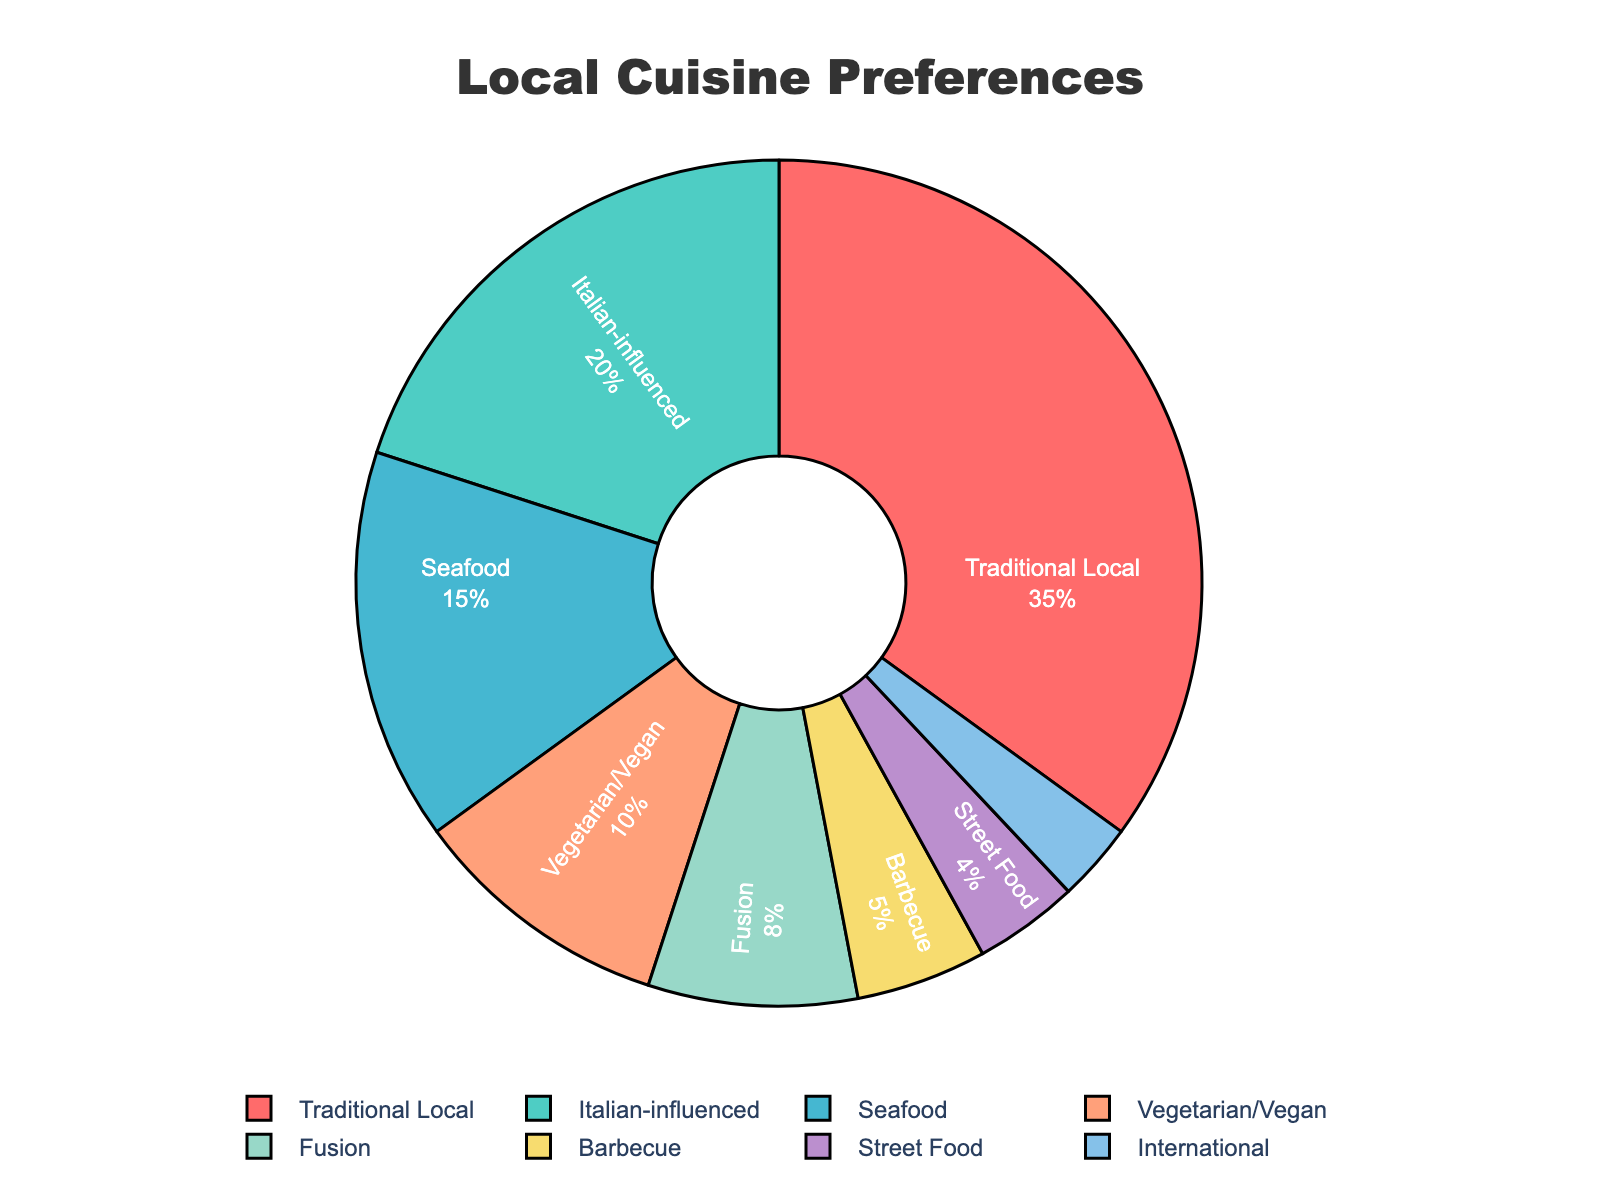Which cuisine has the highest preference among residents? The pie chart shows the percentage distribution of different cuisines. The slice representing "Traditional Local" is the largest, indicating it has the highest preference.
Answer: Traditional Local Which cuisine has the lowest preference among residents? The pie chart shows the percentage distribution of different cuisines. The smallest slice corresponds to "International" cuisine.
Answer: International How much more popular is Traditional Local cuisine compared to Barbecue? The pie chart shows Traditional Local at 35% and Barbecue at 5%. The difference in their popularity is 35% - 5%.
Answer: 30% What is the combined percentage of Seafood and Vegetarian/Vegan preferences? The pie chart shows Seafood at 15% and Vegetarian/Vegan at 10%. So, their combined percentage is 15% + 10%.
Answer: 25% Which is more preferred, Seafood or Italian-influenced cuisine, and by how much? The pie chart shows Seafood at 15% and Italian-influenced at 20%. Italian-influenced cuisine is more preferred by a difference of 20% - 15%.
Answer: Italian-influenced, 5% If you were to combine the categories of Street Food, Barbecue, and International, what would their total percentage be? The pie chart shows Street Food at 4%, Barbecue at 5%, and International at 3%. The combined total is 4% + 5% + 3%.
Answer: 12% What percentage of the preferences is accounted for by cuisines other than Traditional Local, Italian-influenced, and Seafood? The pie chart shows Traditional Local at 35%, Italian-influenced at 20%, and Seafood at 15%. The remaining percentage is 100% - 35% - 20% - 15%.
Answer: 30% Is Fusion cuisine preferred more or less than 10%? The pie chart shows Fusion at 8%, which is less than 10%.
Answer: Less How does the preference for Barbecue compare to Street Food? The pie chart shows Barbecue at 5% and Street Food at 4%. Barbecue is preferred by 1% more than Street Food.
Answer: Barbecue by 1% By what percentage does Traditional Local cuisine exceed the combined preferences of Barbecue, Street Food, and International? The pie chart shows Traditional Local at 35%, and the combined preferences of Barbecue (5%), Street Food (4%), and International (3%) is 12%. Traditional Local exceeds this combined total by 35% - 12%.
Answer: 23% 